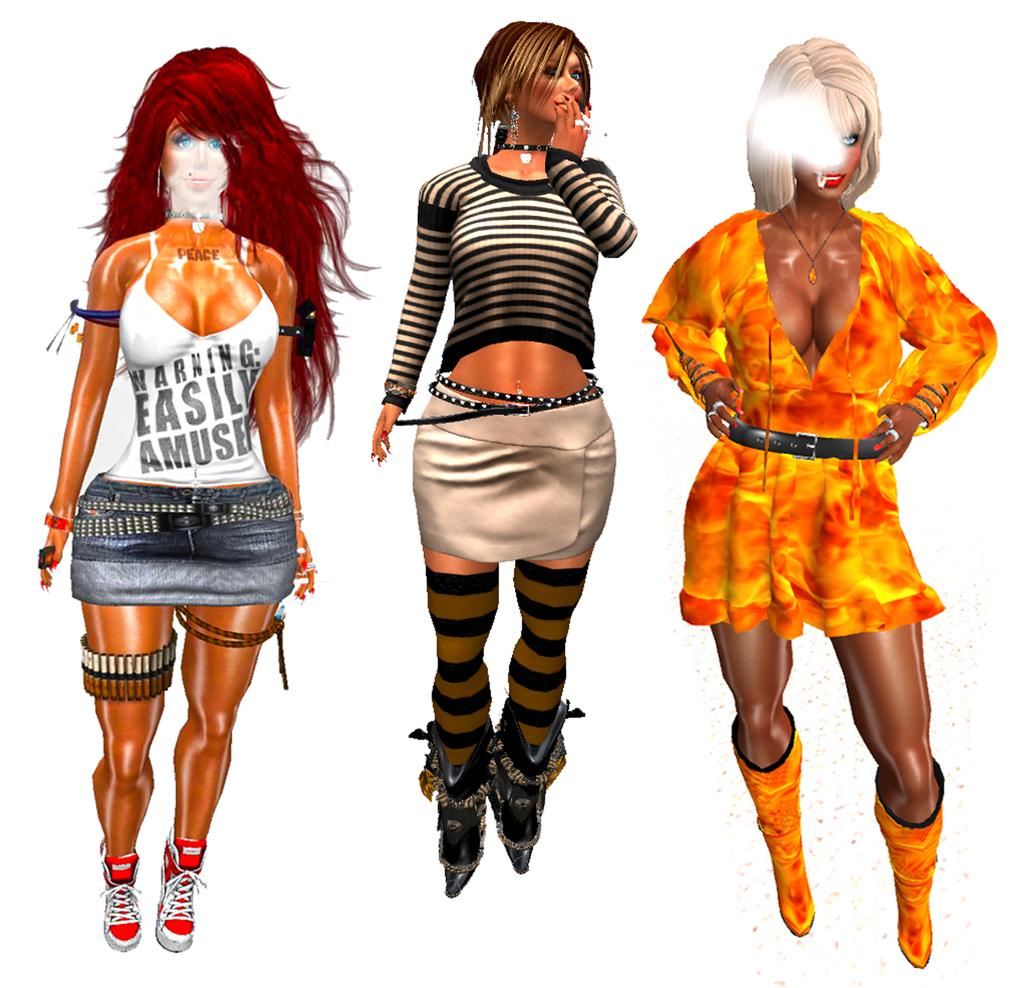<image>
Create a compact narrative representing the image presented. Three cartoons in a row with one whose shirt says "Easily Amuse". 